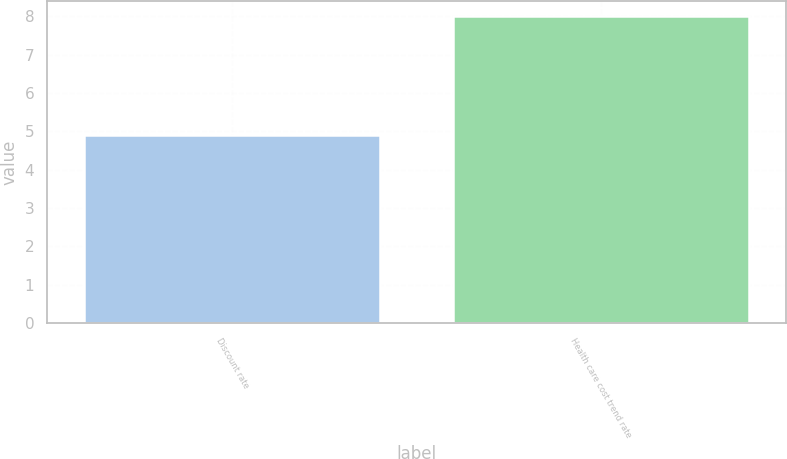Convert chart to OTSL. <chart><loc_0><loc_0><loc_500><loc_500><bar_chart><fcel>Discount rate<fcel>Health care cost trend rate<nl><fcel>4.9<fcel>8<nl></chart> 